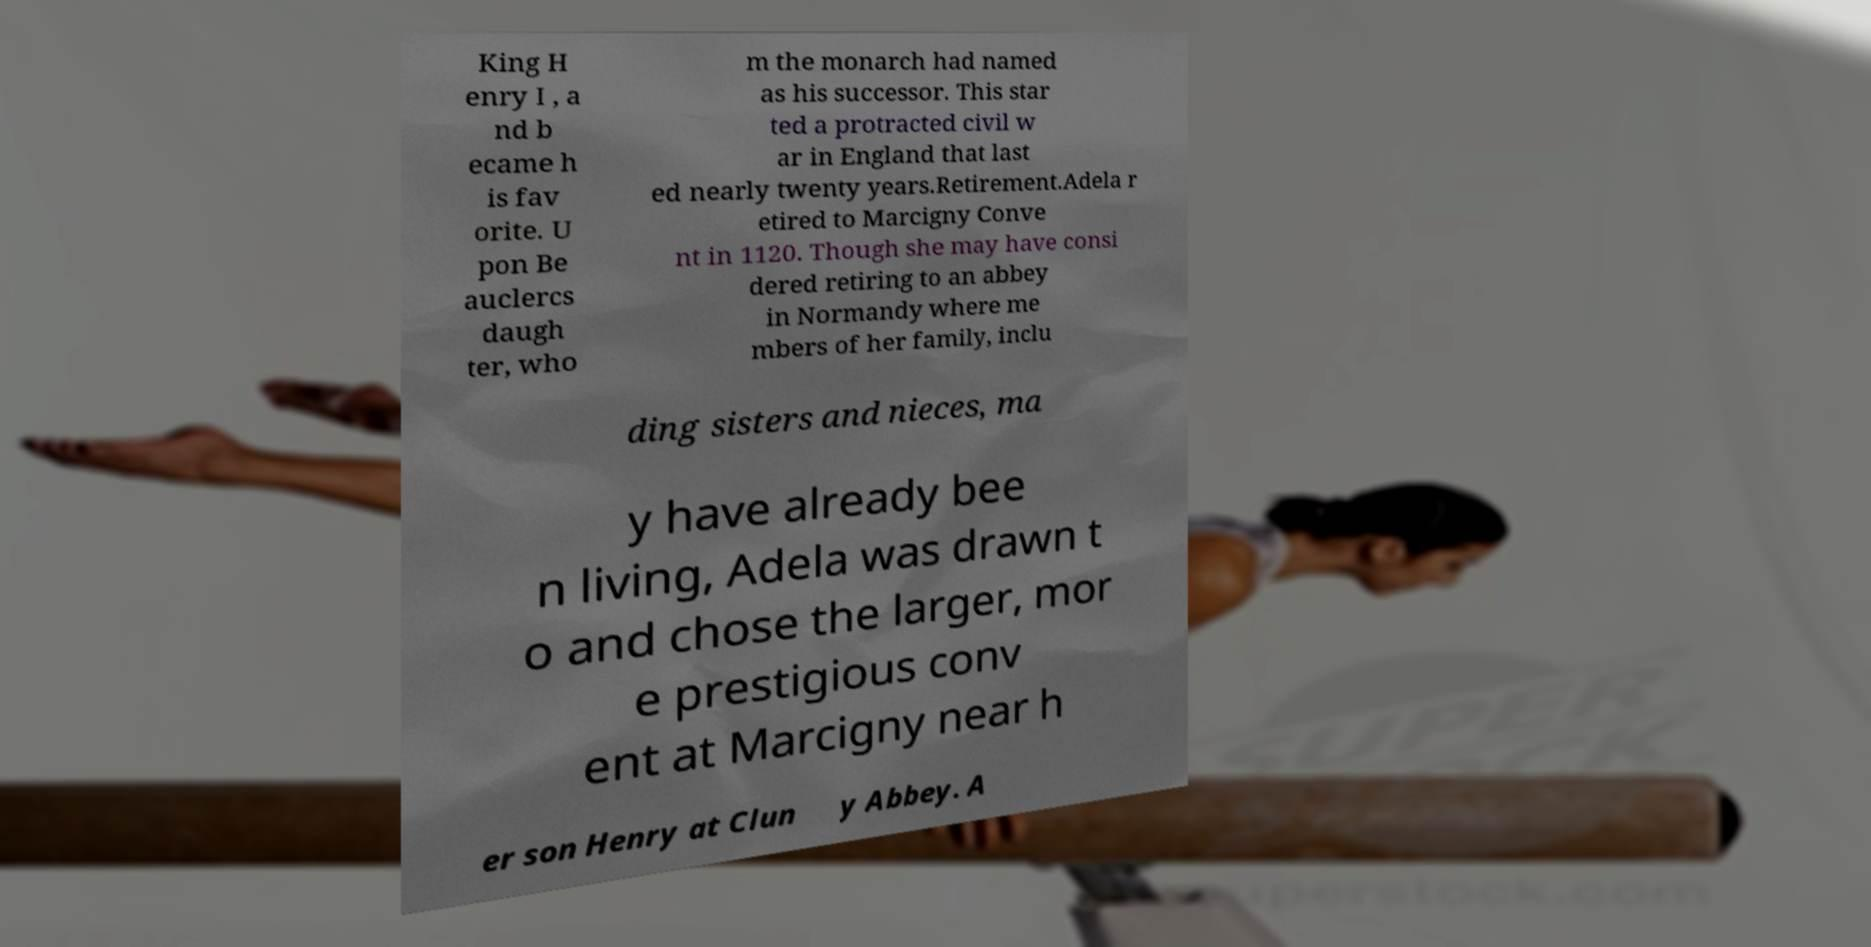Could you extract and type out the text from this image? King H enry I , a nd b ecame h is fav orite. U pon Be auclercs daugh ter, who m the monarch had named as his successor. This star ted a protracted civil w ar in England that last ed nearly twenty years.Retirement.Adela r etired to Marcigny Conve nt in 1120. Though she may have consi dered retiring to an abbey in Normandy where me mbers of her family, inclu ding sisters and nieces, ma y have already bee n living, Adela was drawn t o and chose the larger, mor e prestigious conv ent at Marcigny near h er son Henry at Clun y Abbey. A 